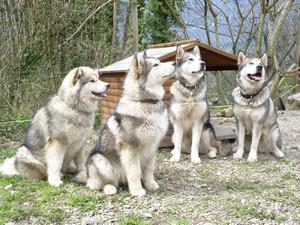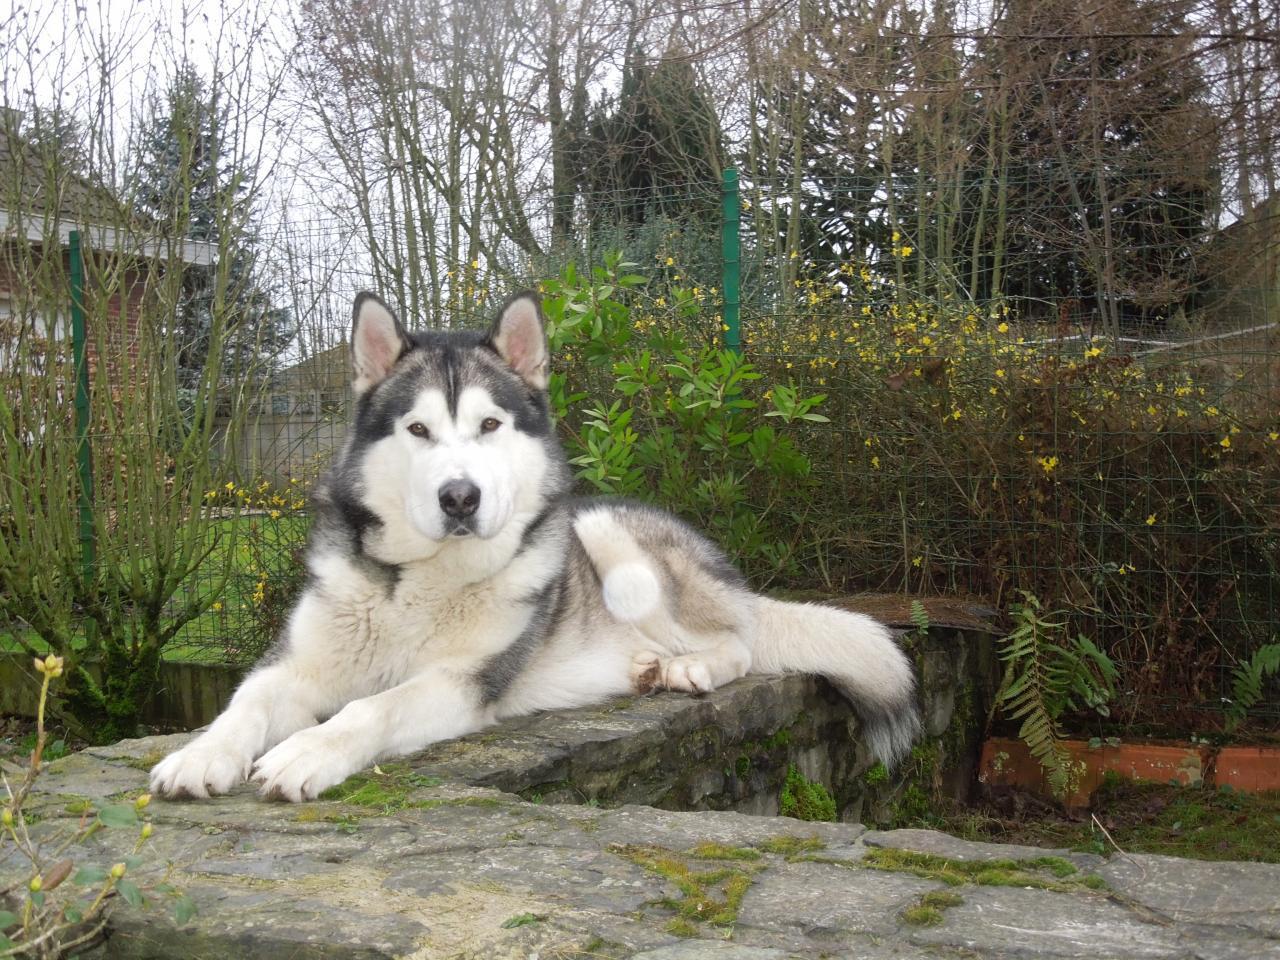The first image is the image on the left, the second image is the image on the right. Given the left and right images, does the statement "In the image on the left, four Malamutes are sitting in the grass in front of a shelter and looking up at something." hold true? Answer yes or no. Yes. The first image is the image on the left, the second image is the image on the right. Given the left and right images, does the statement "In one image, four dogs are sitting in a group, while a single dog is in a second image." hold true? Answer yes or no. Yes. 